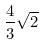Convert formula to latex. <formula><loc_0><loc_0><loc_500><loc_500>\frac { 4 } { 3 } \sqrt { 2 }</formula> 